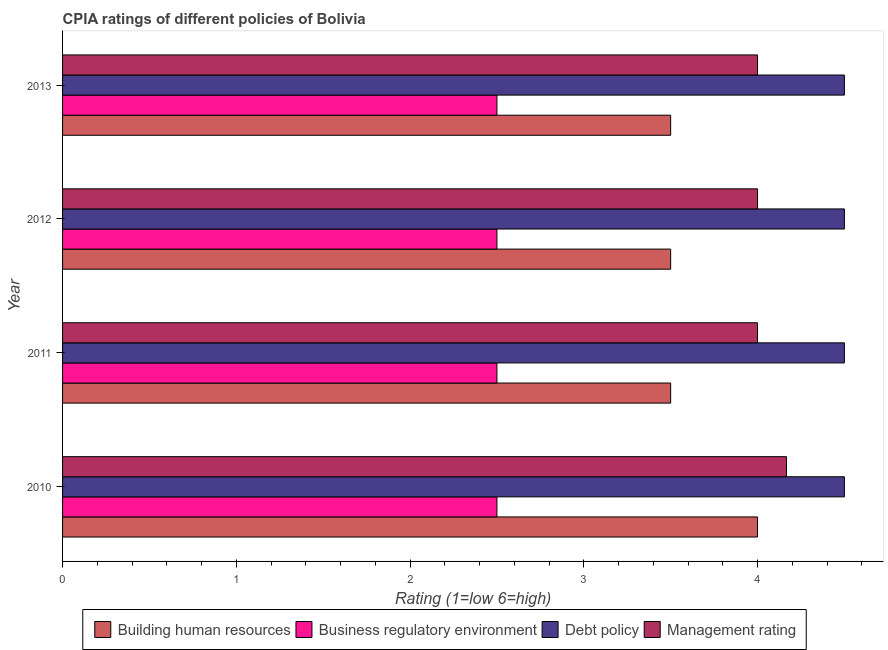How many different coloured bars are there?
Keep it short and to the point. 4. Are the number of bars per tick equal to the number of legend labels?
Your answer should be very brief. Yes. Are the number of bars on each tick of the Y-axis equal?
Your answer should be very brief. Yes. How many bars are there on the 3rd tick from the top?
Provide a succinct answer. 4. What is the label of the 3rd group of bars from the top?
Provide a short and direct response. 2011. Across all years, what is the maximum cpia rating of debt policy?
Give a very brief answer. 4.5. In which year was the cpia rating of business regulatory environment maximum?
Make the answer very short. 2010. What is the total cpia rating of debt policy in the graph?
Ensure brevity in your answer.  18. What is the difference between the cpia rating of building human resources in 2010 and that in 2012?
Keep it short and to the point. 0.5. What is the average cpia rating of management per year?
Keep it short and to the point. 4.04. What is the ratio of the cpia rating of management in 2010 to that in 2011?
Offer a terse response. 1.04. Is the cpia rating of debt policy in 2011 less than that in 2012?
Your answer should be very brief. No. Is the sum of the cpia rating of debt policy in 2011 and 2013 greater than the maximum cpia rating of business regulatory environment across all years?
Provide a succinct answer. Yes. What does the 1st bar from the top in 2011 represents?
Offer a very short reply. Management rating. What does the 4th bar from the bottom in 2011 represents?
Give a very brief answer. Management rating. Are all the bars in the graph horizontal?
Ensure brevity in your answer.  Yes. How many years are there in the graph?
Make the answer very short. 4. What is the difference between two consecutive major ticks on the X-axis?
Your answer should be very brief. 1. Are the values on the major ticks of X-axis written in scientific E-notation?
Make the answer very short. No. How many legend labels are there?
Your response must be concise. 4. How are the legend labels stacked?
Ensure brevity in your answer.  Horizontal. What is the title of the graph?
Give a very brief answer. CPIA ratings of different policies of Bolivia. Does "Other Minerals" appear as one of the legend labels in the graph?
Give a very brief answer. No. What is the Rating (1=low 6=high) in Debt policy in 2010?
Your answer should be compact. 4.5. What is the Rating (1=low 6=high) in Management rating in 2010?
Give a very brief answer. 4.17. What is the Rating (1=low 6=high) of Building human resources in 2011?
Provide a short and direct response. 3.5. What is the Rating (1=low 6=high) in Business regulatory environment in 2011?
Give a very brief answer. 2.5. What is the Rating (1=low 6=high) of Management rating in 2011?
Provide a short and direct response. 4. What is the Rating (1=low 6=high) in Building human resources in 2012?
Keep it short and to the point. 3.5. What is the Rating (1=low 6=high) of Management rating in 2012?
Keep it short and to the point. 4. What is the Rating (1=low 6=high) in Business regulatory environment in 2013?
Offer a terse response. 2.5. What is the Rating (1=low 6=high) in Management rating in 2013?
Offer a very short reply. 4. Across all years, what is the maximum Rating (1=low 6=high) in Building human resources?
Offer a terse response. 4. Across all years, what is the maximum Rating (1=low 6=high) in Business regulatory environment?
Ensure brevity in your answer.  2.5. Across all years, what is the maximum Rating (1=low 6=high) in Management rating?
Give a very brief answer. 4.17. Across all years, what is the minimum Rating (1=low 6=high) in Building human resources?
Your answer should be very brief. 3.5. Across all years, what is the minimum Rating (1=low 6=high) in Debt policy?
Make the answer very short. 4.5. What is the total Rating (1=low 6=high) in Business regulatory environment in the graph?
Keep it short and to the point. 10. What is the total Rating (1=low 6=high) in Debt policy in the graph?
Make the answer very short. 18. What is the total Rating (1=low 6=high) in Management rating in the graph?
Make the answer very short. 16.17. What is the difference between the Rating (1=low 6=high) in Business regulatory environment in 2010 and that in 2011?
Ensure brevity in your answer.  0. What is the difference between the Rating (1=low 6=high) of Debt policy in 2010 and that in 2011?
Provide a succinct answer. 0. What is the difference between the Rating (1=low 6=high) of Management rating in 2010 and that in 2011?
Your answer should be compact. 0.17. What is the difference between the Rating (1=low 6=high) of Business regulatory environment in 2010 and that in 2012?
Offer a terse response. 0. What is the difference between the Rating (1=low 6=high) in Management rating in 2010 and that in 2012?
Provide a succinct answer. 0.17. What is the difference between the Rating (1=low 6=high) of Building human resources in 2010 and that in 2013?
Make the answer very short. 0.5. What is the difference between the Rating (1=low 6=high) in Management rating in 2010 and that in 2013?
Keep it short and to the point. 0.17. What is the difference between the Rating (1=low 6=high) in Business regulatory environment in 2011 and that in 2012?
Ensure brevity in your answer.  0. What is the difference between the Rating (1=low 6=high) in Management rating in 2011 and that in 2012?
Your response must be concise. 0. What is the difference between the Rating (1=low 6=high) in Building human resources in 2011 and that in 2013?
Make the answer very short. 0. What is the difference between the Rating (1=low 6=high) in Management rating in 2011 and that in 2013?
Give a very brief answer. 0. What is the difference between the Rating (1=low 6=high) in Building human resources in 2012 and that in 2013?
Give a very brief answer. 0. What is the difference between the Rating (1=low 6=high) of Debt policy in 2012 and that in 2013?
Keep it short and to the point. 0. What is the difference between the Rating (1=low 6=high) of Building human resources in 2010 and the Rating (1=low 6=high) of Management rating in 2011?
Provide a succinct answer. 0. What is the difference between the Rating (1=low 6=high) of Business regulatory environment in 2010 and the Rating (1=low 6=high) of Debt policy in 2011?
Keep it short and to the point. -2. What is the difference between the Rating (1=low 6=high) of Business regulatory environment in 2010 and the Rating (1=low 6=high) of Management rating in 2011?
Keep it short and to the point. -1.5. What is the difference between the Rating (1=low 6=high) in Debt policy in 2010 and the Rating (1=low 6=high) in Management rating in 2011?
Your response must be concise. 0.5. What is the difference between the Rating (1=low 6=high) of Building human resources in 2010 and the Rating (1=low 6=high) of Business regulatory environment in 2012?
Keep it short and to the point. 1.5. What is the difference between the Rating (1=low 6=high) of Building human resources in 2010 and the Rating (1=low 6=high) of Debt policy in 2012?
Offer a terse response. -0.5. What is the difference between the Rating (1=low 6=high) of Building human resources in 2010 and the Rating (1=low 6=high) of Debt policy in 2013?
Give a very brief answer. -0.5. What is the difference between the Rating (1=low 6=high) of Business regulatory environment in 2010 and the Rating (1=low 6=high) of Debt policy in 2013?
Offer a terse response. -2. What is the difference between the Rating (1=low 6=high) of Business regulatory environment in 2010 and the Rating (1=low 6=high) of Management rating in 2013?
Ensure brevity in your answer.  -1.5. What is the difference between the Rating (1=low 6=high) of Building human resources in 2011 and the Rating (1=low 6=high) of Business regulatory environment in 2012?
Your response must be concise. 1. What is the difference between the Rating (1=low 6=high) in Building human resources in 2011 and the Rating (1=low 6=high) in Debt policy in 2013?
Give a very brief answer. -1. What is the difference between the Rating (1=low 6=high) of Building human resources in 2011 and the Rating (1=low 6=high) of Management rating in 2013?
Ensure brevity in your answer.  -0.5. What is the difference between the Rating (1=low 6=high) of Business regulatory environment in 2011 and the Rating (1=low 6=high) of Debt policy in 2013?
Make the answer very short. -2. What is the difference between the Rating (1=low 6=high) in Building human resources in 2012 and the Rating (1=low 6=high) in Management rating in 2013?
Offer a terse response. -0.5. What is the difference between the Rating (1=low 6=high) of Debt policy in 2012 and the Rating (1=low 6=high) of Management rating in 2013?
Give a very brief answer. 0.5. What is the average Rating (1=low 6=high) of Building human resources per year?
Your answer should be compact. 3.62. What is the average Rating (1=low 6=high) in Debt policy per year?
Provide a succinct answer. 4.5. What is the average Rating (1=low 6=high) in Management rating per year?
Provide a short and direct response. 4.04. In the year 2010, what is the difference between the Rating (1=low 6=high) of Building human resources and Rating (1=low 6=high) of Business regulatory environment?
Your response must be concise. 1.5. In the year 2010, what is the difference between the Rating (1=low 6=high) of Business regulatory environment and Rating (1=low 6=high) of Debt policy?
Your response must be concise. -2. In the year 2010, what is the difference between the Rating (1=low 6=high) in Business regulatory environment and Rating (1=low 6=high) in Management rating?
Make the answer very short. -1.67. In the year 2010, what is the difference between the Rating (1=low 6=high) of Debt policy and Rating (1=low 6=high) of Management rating?
Offer a terse response. 0.33. In the year 2011, what is the difference between the Rating (1=low 6=high) in Building human resources and Rating (1=low 6=high) in Business regulatory environment?
Ensure brevity in your answer.  1. In the year 2011, what is the difference between the Rating (1=low 6=high) in Building human resources and Rating (1=low 6=high) in Management rating?
Offer a very short reply. -0.5. In the year 2011, what is the difference between the Rating (1=low 6=high) in Business regulatory environment and Rating (1=low 6=high) in Management rating?
Offer a very short reply. -1.5. In the year 2012, what is the difference between the Rating (1=low 6=high) in Building human resources and Rating (1=low 6=high) in Business regulatory environment?
Ensure brevity in your answer.  1. In the year 2012, what is the difference between the Rating (1=low 6=high) in Building human resources and Rating (1=low 6=high) in Debt policy?
Provide a short and direct response. -1. In the year 2012, what is the difference between the Rating (1=low 6=high) of Debt policy and Rating (1=low 6=high) of Management rating?
Provide a short and direct response. 0.5. In the year 2013, what is the difference between the Rating (1=low 6=high) of Building human resources and Rating (1=low 6=high) of Business regulatory environment?
Make the answer very short. 1. In the year 2013, what is the difference between the Rating (1=low 6=high) of Building human resources and Rating (1=low 6=high) of Debt policy?
Make the answer very short. -1. In the year 2013, what is the difference between the Rating (1=low 6=high) in Building human resources and Rating (1=low 6=high) in Management rating?
Your answer should be very brief. -0.5. In the year 2013, what is the difference between the Rating (1=low 6=high) of Debt policy and Rating (1=low 6=high) of Management rating?
Provide a succinct answer. 0.5. What is the ratio of the Rating (1=low 6=high) of Building human resources in 2010 to that in 2011?
Give a very brief answer. 1.14. What is the ratio of the Rating (1=low 6=high) in Management rating in 2010 to that in 2011?
Your response must be concise. 1.04. What is the ratio of the Rating (1=low 6=high) of Business regulatory environment in 2010 to that in 2012?
Offer a terse response. 1. What is the ratio of the Rating (1=low 6=high) of Management rating in 2010 to that in 2012?
Ensure brevity in your answer.  1.04. What is the ratio of the Rating (1=low 6=high) in Management rating in 2010 to that in 2013?
Provide a short and direct response. 1.04. What is the ratio of the Rating (1=low 6=high) of Building human resources in 2011 to that in 2012?
Offer a terse response. 1. What is the ratio of the Rating (1=low 6=high) of Business regulatory environment in 2011 to that in 2012?
Your answer should be very brief. 1. What is the ratio of the Rating (1=low 6=high) of Debt policy in 2011 to that in 2012?
Your answer should be compact. 1. What is the ratio of the Rating (1=low 6=high) of Building human resources in 2011 to that in 2013?
Your answer should be very brief. 1. What is the ratio of the Rating (1=low 6=high) of Business regulatory environment in 2011 to that in 2013?
Make the answer very short. 1. What is the ratio of the Rating (1=low 6=high) in Debt policy in 2011 to that in 2013?
Give a very brief answer. 1. What is the ratio of the Rating (1=low 6=high) of Management rating in 2011 to that in 2013?
Provide a succinct answer. 1. What is the ratio of the Rating (1=low 6=high) of Business regulatory environment in 2012 to that in 2013?
Make the answer very short. 1. What is the ratio of the Rating (1=low 6=high) of Debt policy in 2012 to that in 2013?
Offer a very short reply. 1. What is the difference between the highest and the second highest Rating (1=low 6=high) of Management rating?
Provide a succinct answer. 0.17. What is the difference between the highest and the lowest Rating (1=low 6=high) in Building human resources?
Give a very brief answer. 0.5. What is the difference between the highest and the lowest Rating (1=low 6=high) of Management rating?
Your answer should be very brief. 0.17. 